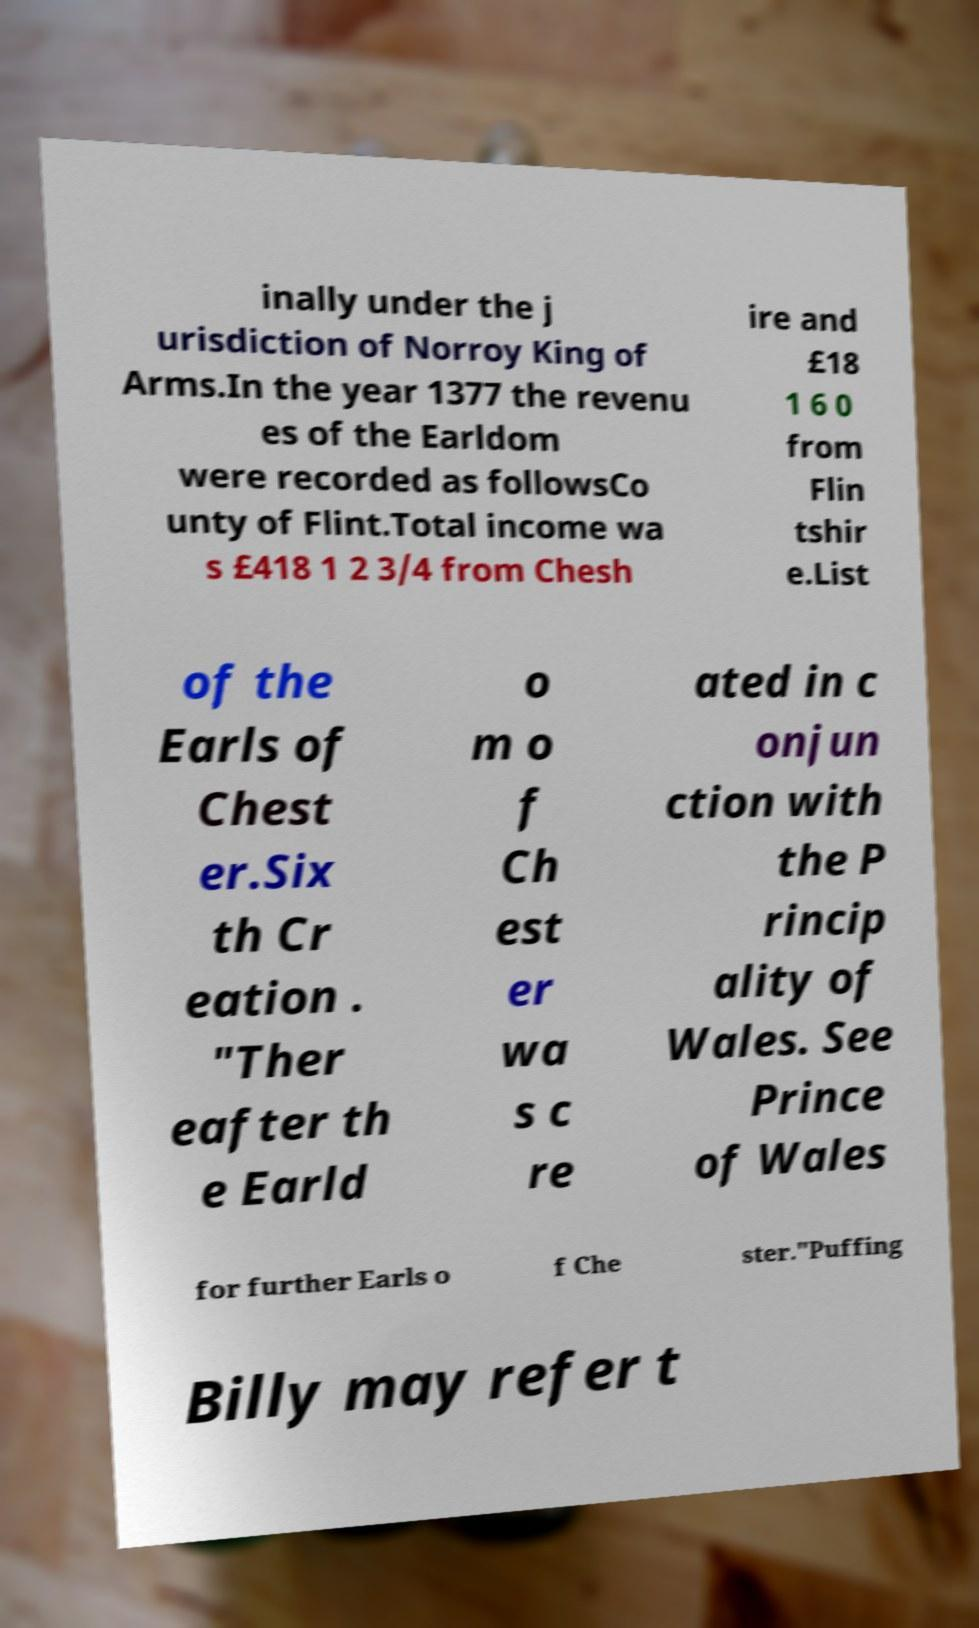There's text embedded in this image that I need extracted. Can you transcribe it verbatim? inally under the j urisdiction of Norroy King of Arms.In the year 1377 the revenu es of the Earldom were recorded as followsCo unty of Flint.Total income wa s £418 1 2 3/4 from Chesh ire and £18 1 6 0 from Flin tshir e.List of the Earls of Chest er.Six th Cr eation . "Ther eafter th e Earld o m o f Ch est er wa s c re ated in c onjun ction with the P rincip ality of Wales. See Prince of Wales for further Earls o f Che ster."Puffing Billy may refer t 